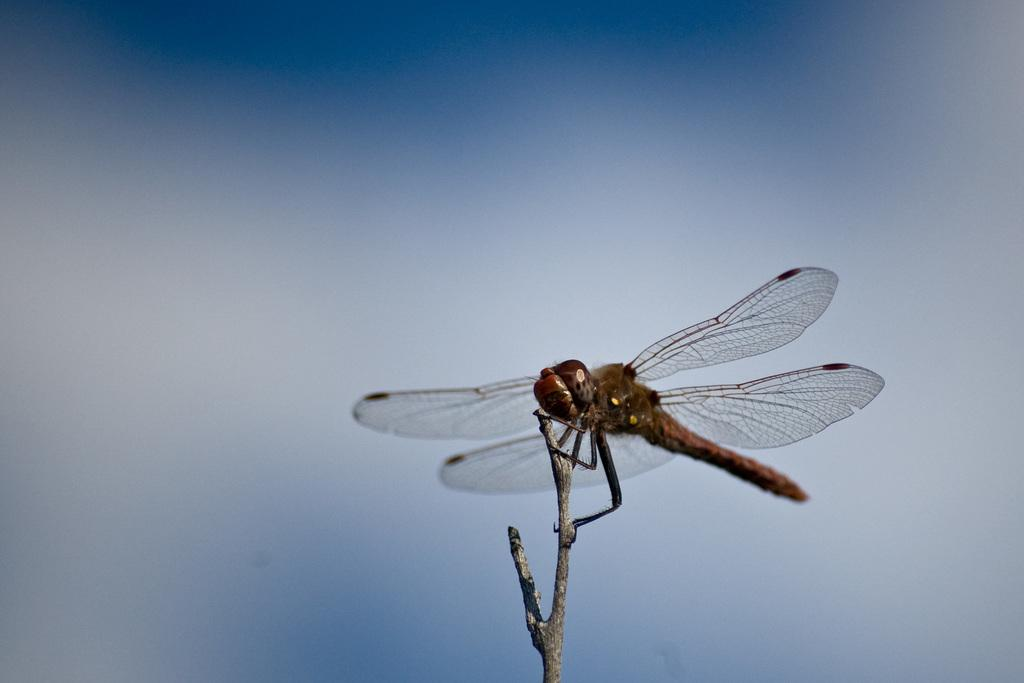What type of creature can be seen on the right side of the image? There is an insect on the right side of the image. What features does the insect have? The insect has wings and legs. Where is the insect located in the image? The insect is standing on a branch of a tree. What color is the background of the image? The background of the image is blue in color. Can you see any corn growing in the image? There is no corn present in the image; it features an insect on a tree branch with a blue background. 